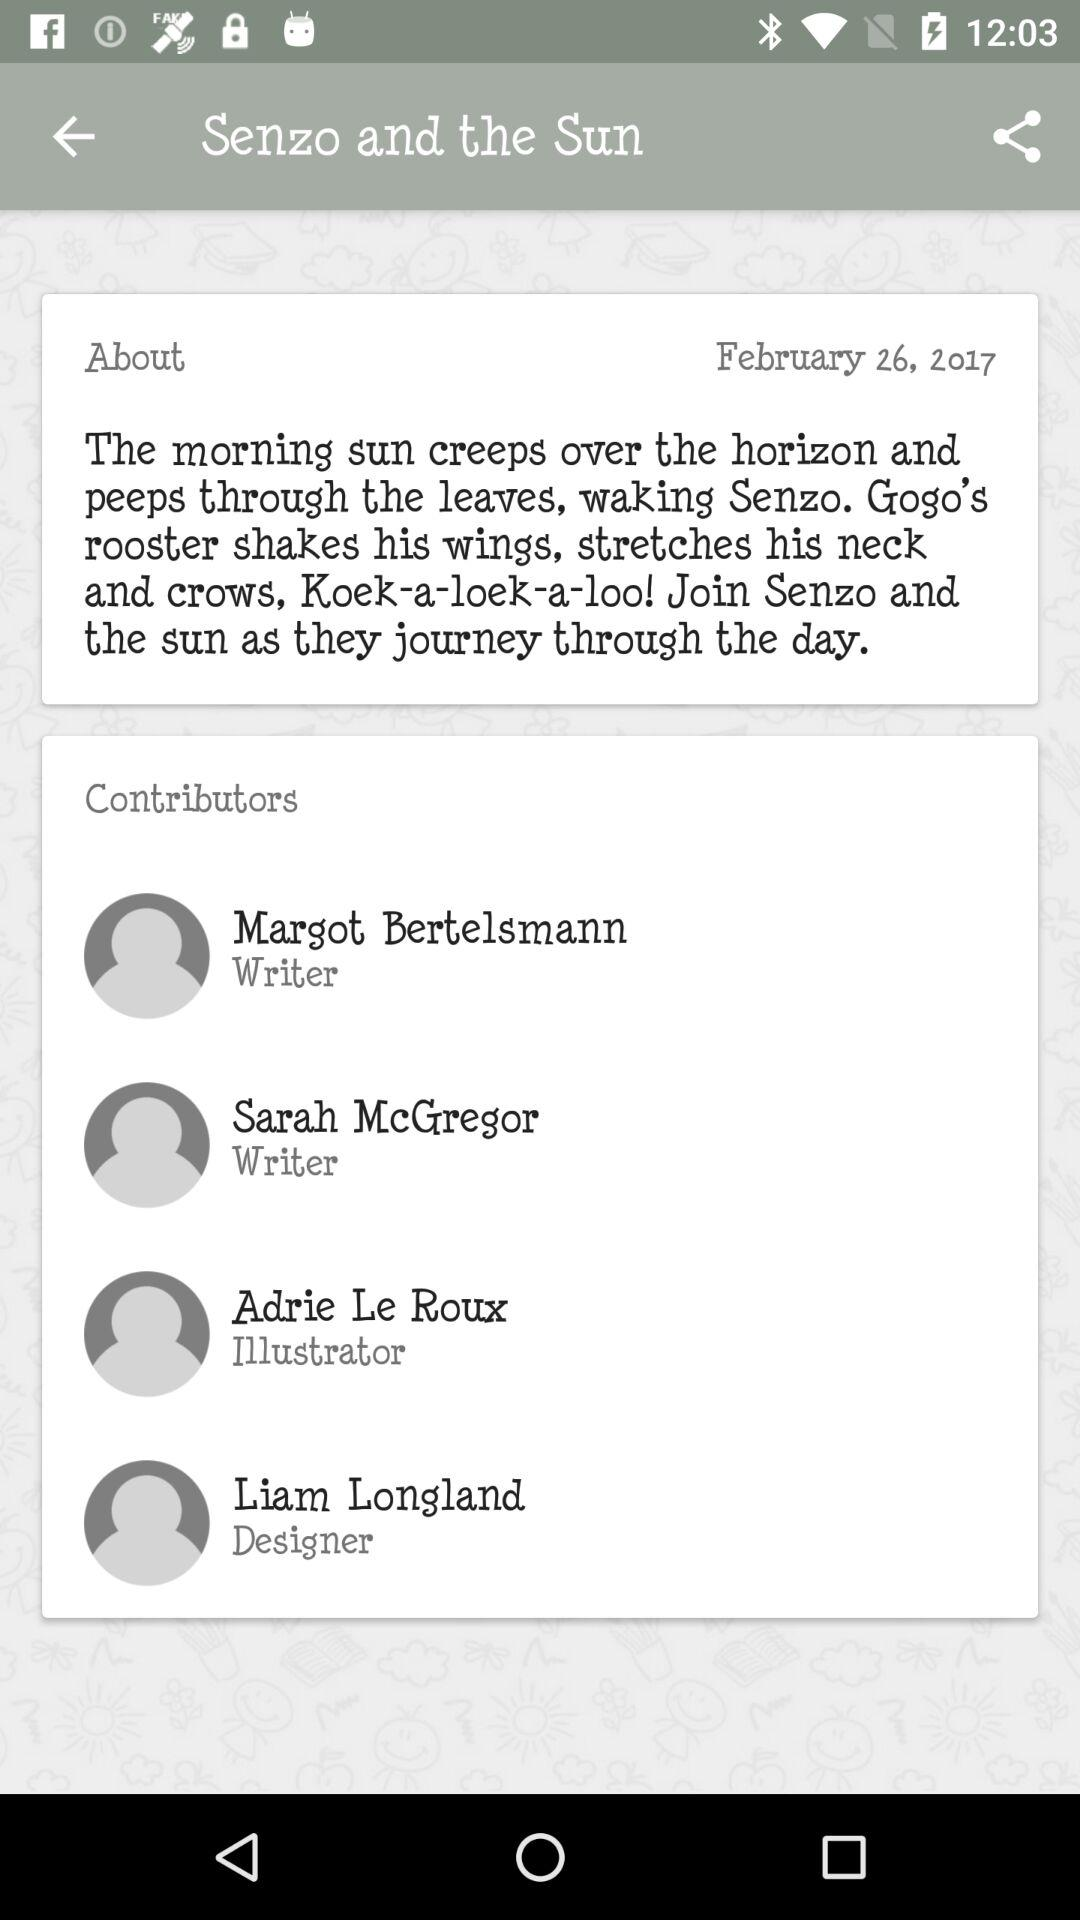When was the article written? The article was written on February 26, 2017. 